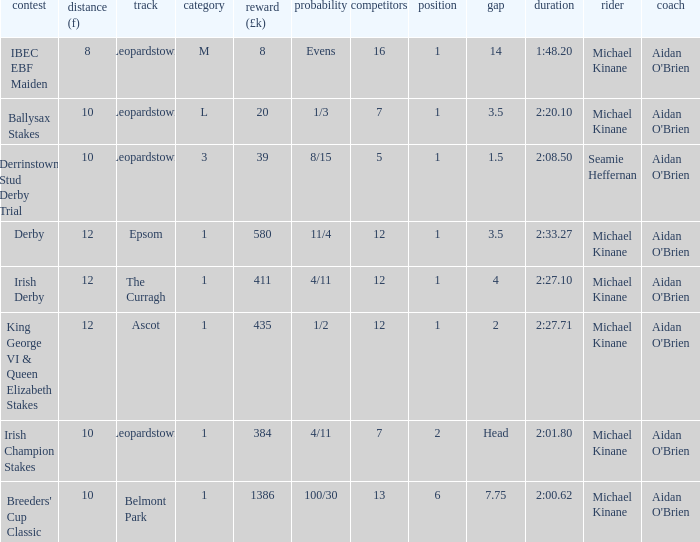Which Class has a Jockey of michael kinane on 2:27.71? 1.0. 